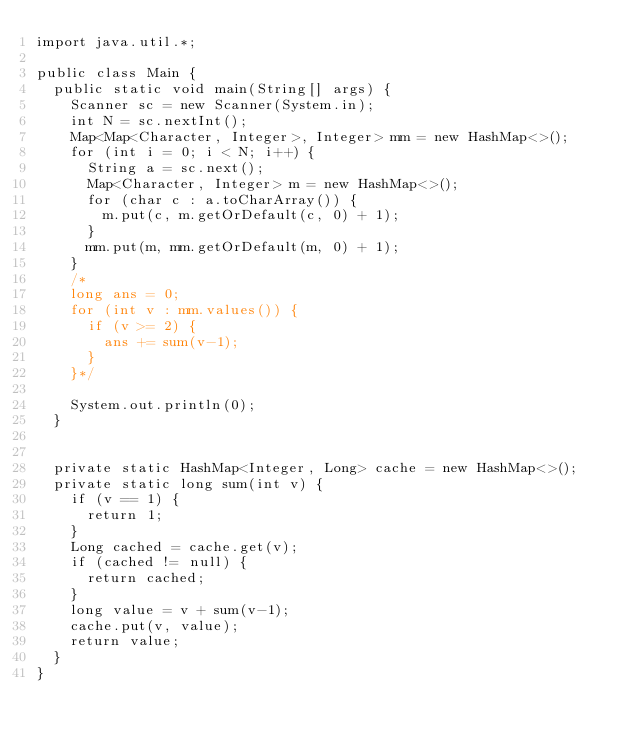Convert code to text. <code><loc_0><loc_0><loc_500><loc_500><_Java_>import java.util.*;

public class Main {
  public static void main(String[] args) {
    Scanner sc = new Scanner(System.in);
    int N = sc.nextInt();
    Map<Map<Character, Integer>, Integer> mm = new HashMap<>();
    for (int i = 0; i < N; i++) {
      String a = sc.next();
      Map<Character, Integer> m = new HashMap<>();
      for (char c : a.toCharArray()) {
        m.put(c, m.getOrDefault(c, 0) + 1);
      }
      mm.put(m, mm.getOrDefault(m, 0) + 1);
    }
    /*
    long ans = 0;
    for (int v : mm.values()) {
      if (v >= 2) {
        ans += sum(v-1);
      }
    }*/
    
    System.out.println(0);
  }


  private static HashMap<Integer, Long> cache = new HashMap<>();
  private static long sum(int v) {
    if (v == 1) {
      return 1;
    }
    Long cached = cache.get(v);
    if (cached != null) {
      return cached;
    }
    long value = v + sum(v-1);
    cache.put(v, value);
    return value;
  }
}</code> 